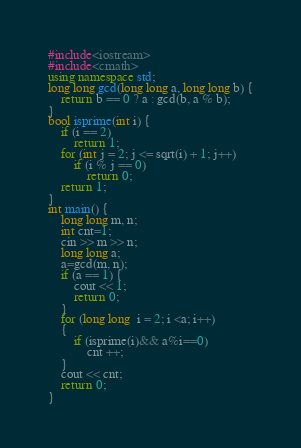Convert code to text. <code><loc_0><loc_0><loc_500><loc_500><_C++_>#include<iostream>
#include<cmath>
using namespace std;
long long gcd(long long a, long long b) {
	return b == 0 ? a : gcd(b, a % b);
}
bool isprime(int i) {
	if (i == 2)
		return 1;
	for (int j = 2; j <= sqrt(i) + 1; j++)
		if (i % j == 0)
			return 0;
	return 1;
}
int main() {
	long long m, n;
	int cnt=1;
	cin >> m >> n;
	long long a;
	a=gcd(m, n);
	if (a == 1) {
		cout << 1;
		return 0;
	}
	for (long long  i = 2; i <a; i++)
	{
		if (isprime(i)&& a%i==0)
			cnt ++;
	}
	cout << cnt;
	return 0;
}</code> 